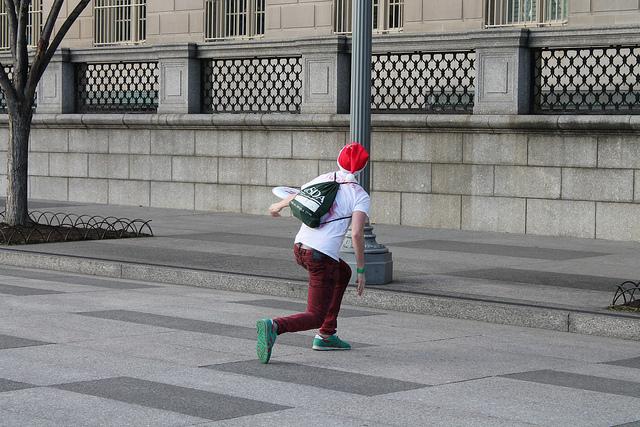Is this kid running across a street?
Answer briefly. Yes. What color shoes is this person wearing?
Short answer required. Green. Is the kid wearing a hat?
Be succinct. Yes. 